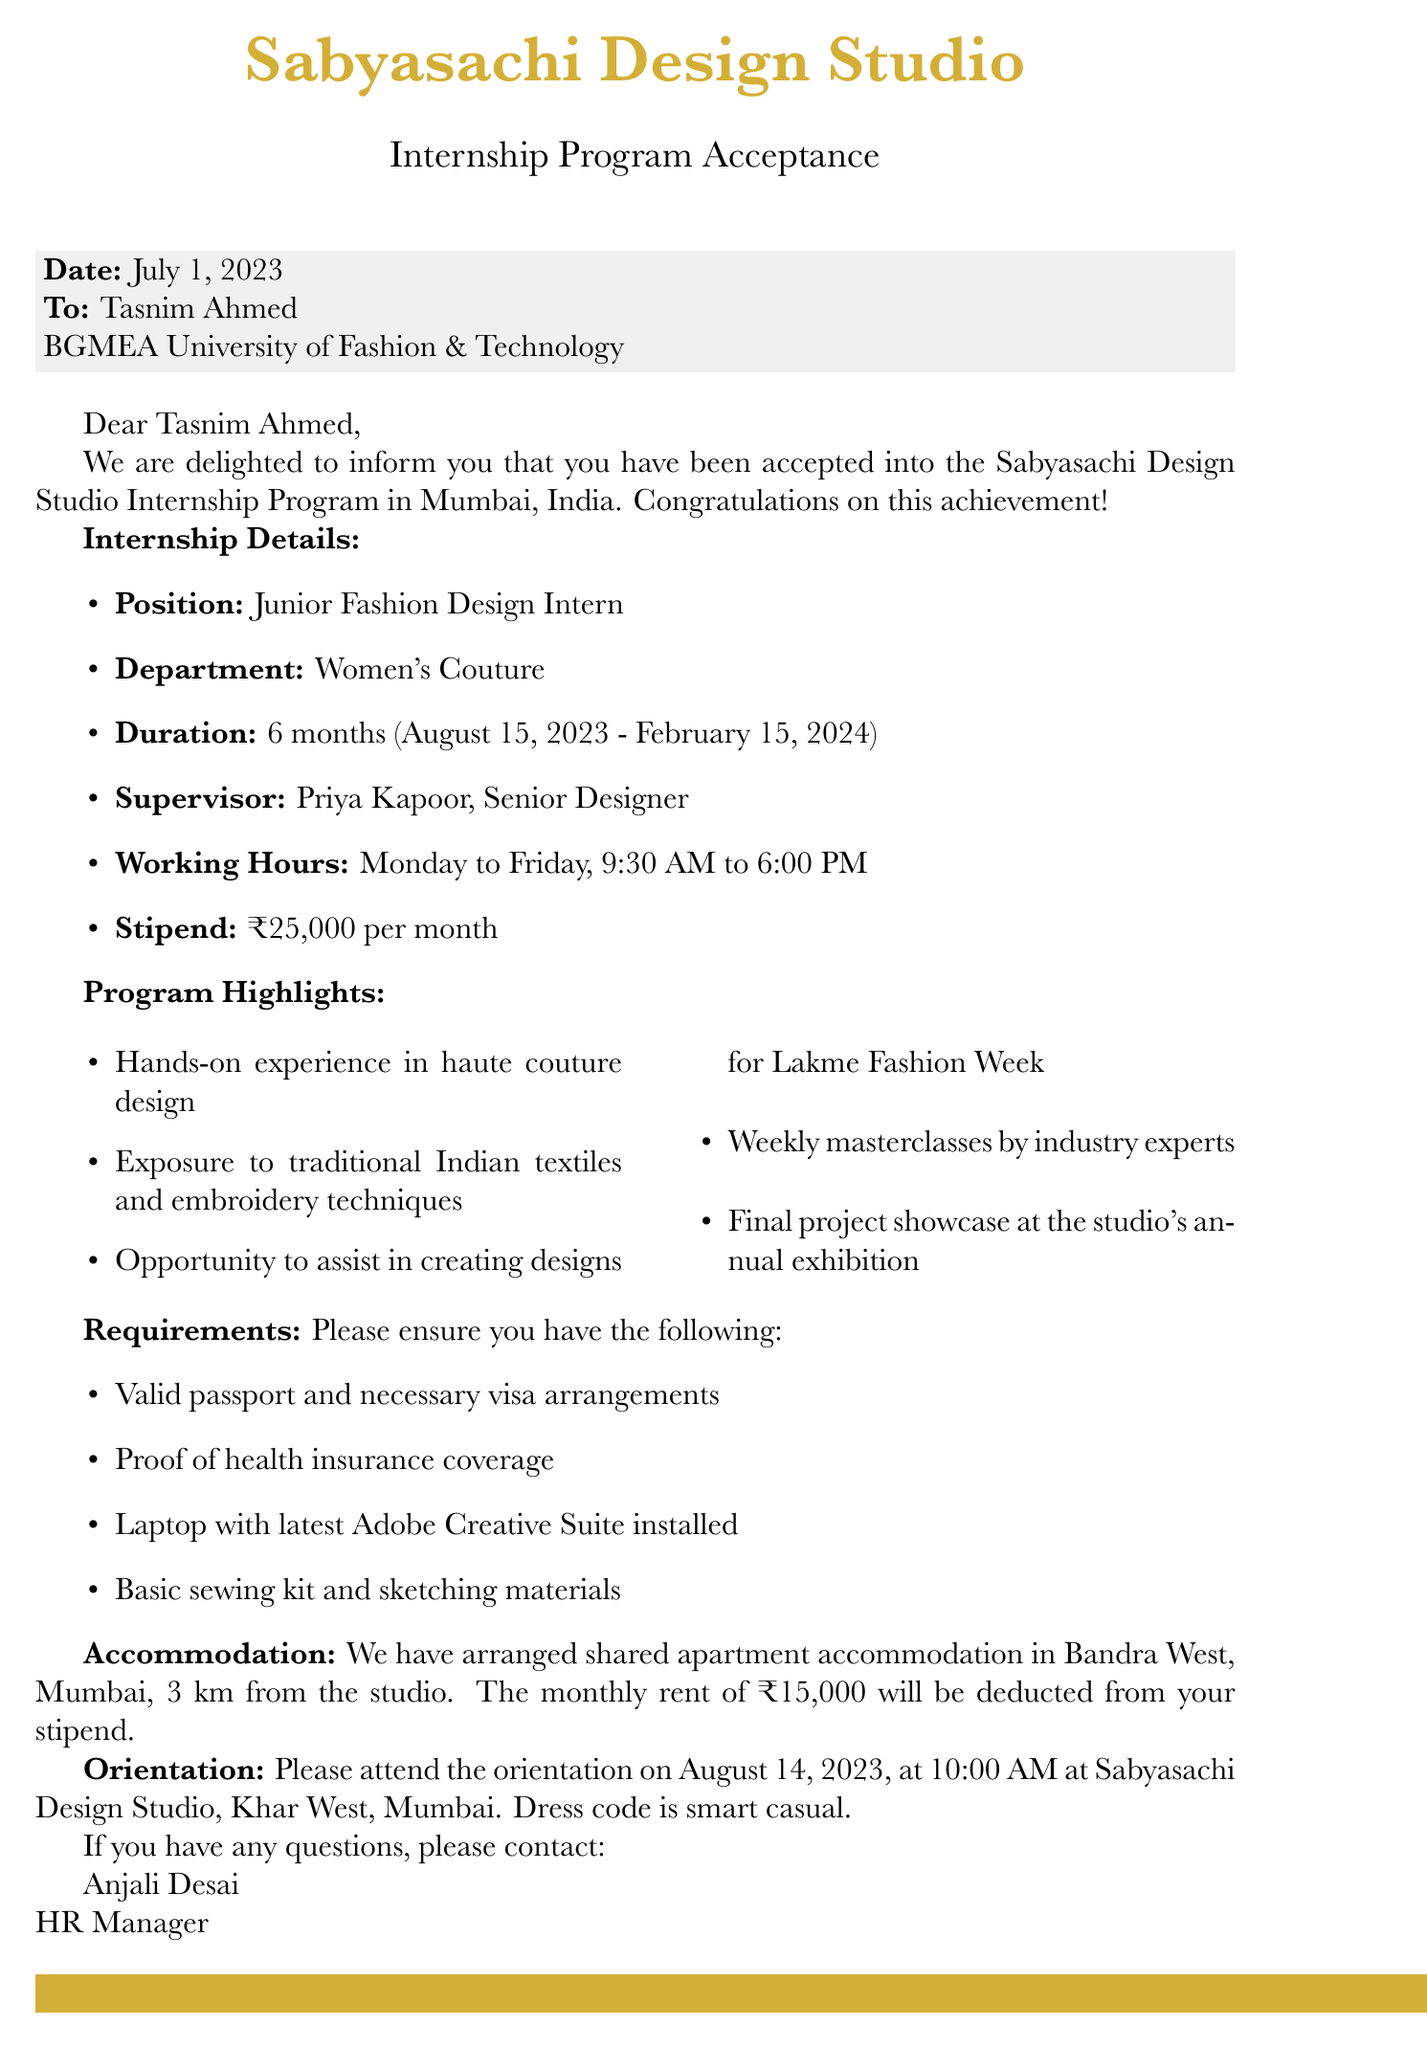what is the name of the internship program? The name of the internship program is explicitly stated in the letter.
Answer: Sabyasachi Design Studio Internship Program who is the supervisor for the internship? The document specifies the supervisor's name in the internship details section.
Answer: Priya Kapoor what is the duration of the internship? The duration is clearly outlined in the internship details.
Answer: 6 months how much is the monthly stipend for the intern? This information is provided in the internship details section of the document.
Answer: ₹25,000 when is the orientation date? The orientation date is mentioned under the orientation details.
Answer: August 14, 2023 what is the location of the accommodation? The accommodation details give a specific location for the shared apartment.
Answer: Bandra West, Mumbai how far is the accommodation from the studio? The distance is clearly stated in the accommodation section.
Answer: 3 km what should be the dress code for the orientation? The document contains specific instructions about the dress code for the orientation.
Answer: Smart casual who is the contact person for further inquiries? This information is provided at the end of the letter, specifying the contact person.
Answer: Anjali Desai 